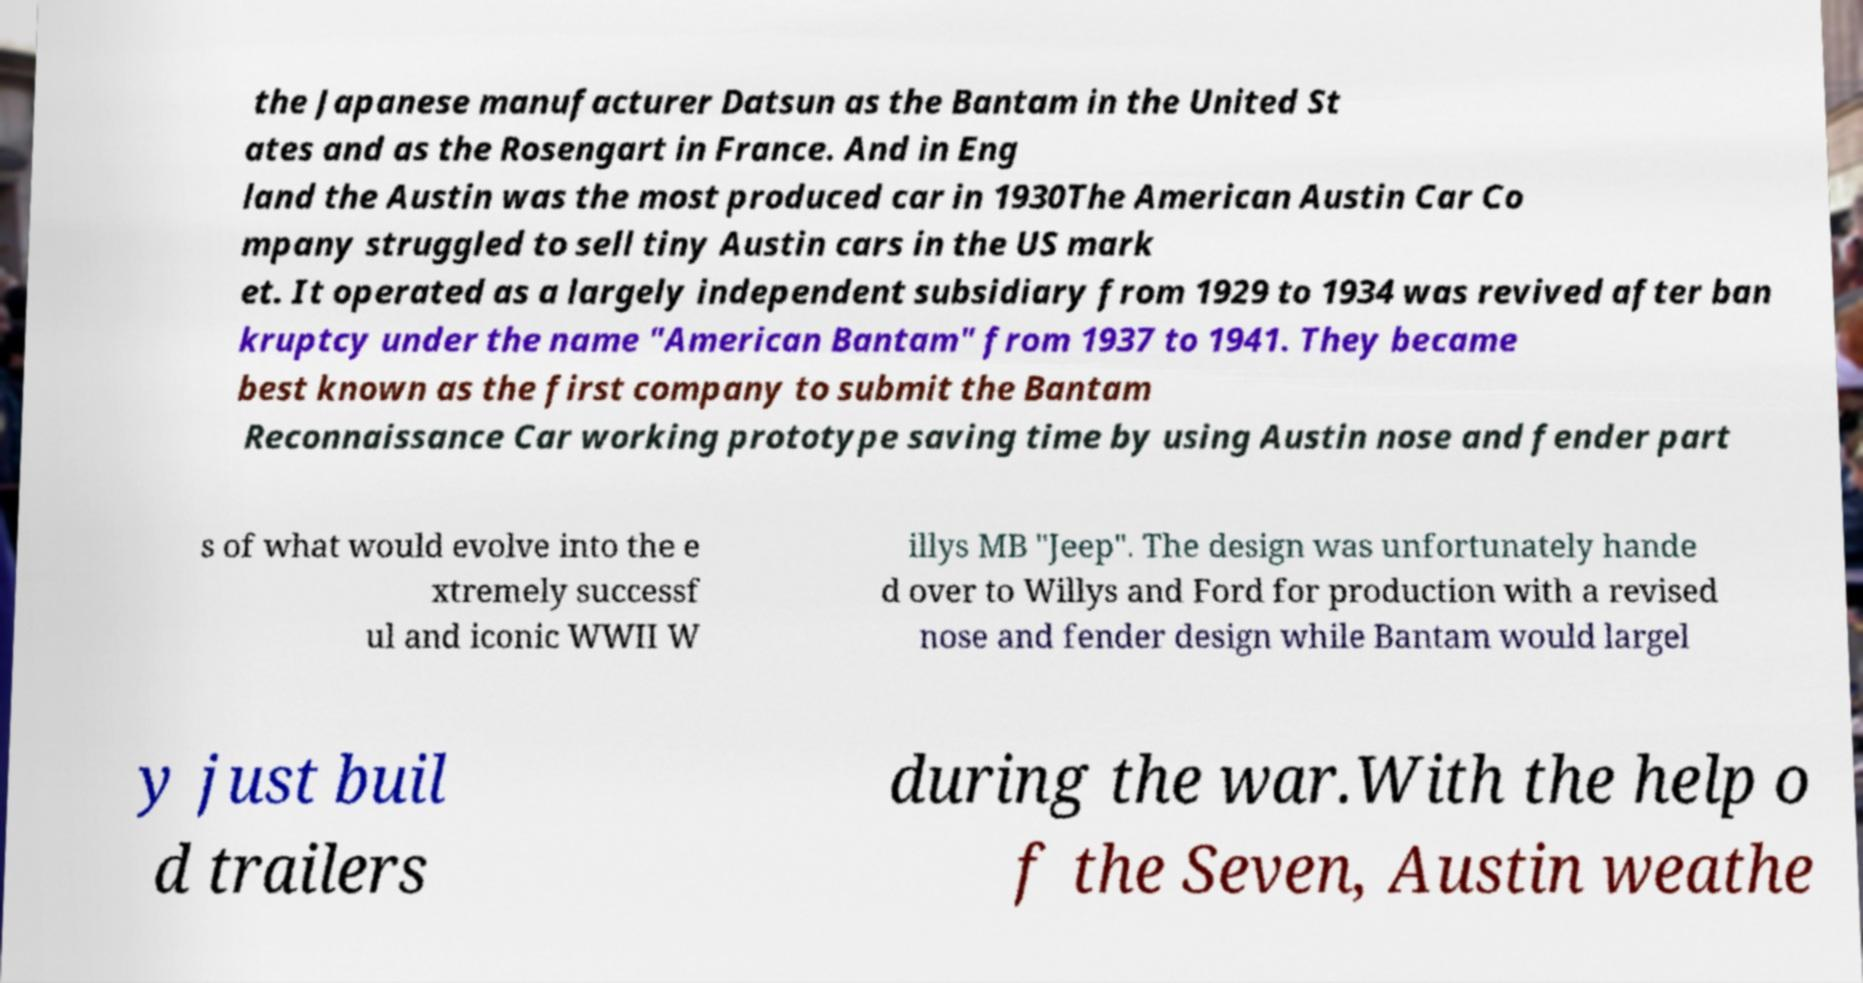Could you extract and type out the text from this image? the Japanese manufacturer Datsun as the Bantam in the United St ates and as the Rosengart in France. And in Eng land the Austin was the most produced car in 1930The American Austin Car Co mpany struggled to sell tiny Austin cars in the US mark et. It operated as a largely independent subsidiary from 1929 to 1934 was revived after ban kruptcy under the name "American Bantam" from 1937 to 1941. They became best known as the first company to submit the Bantam Reconnaissance Car working prototype saving time by using Austin nose and fender part s of what would evolve into the e xtremely successf ul and iconic WWII W illys MB "Jeep". The design was unfortunately hande d over to Willys and Ford for production with a revised nose and fender design while Bantam would largel y just buil d trailers during the war.With the help o f the Seven, Austin weathe 